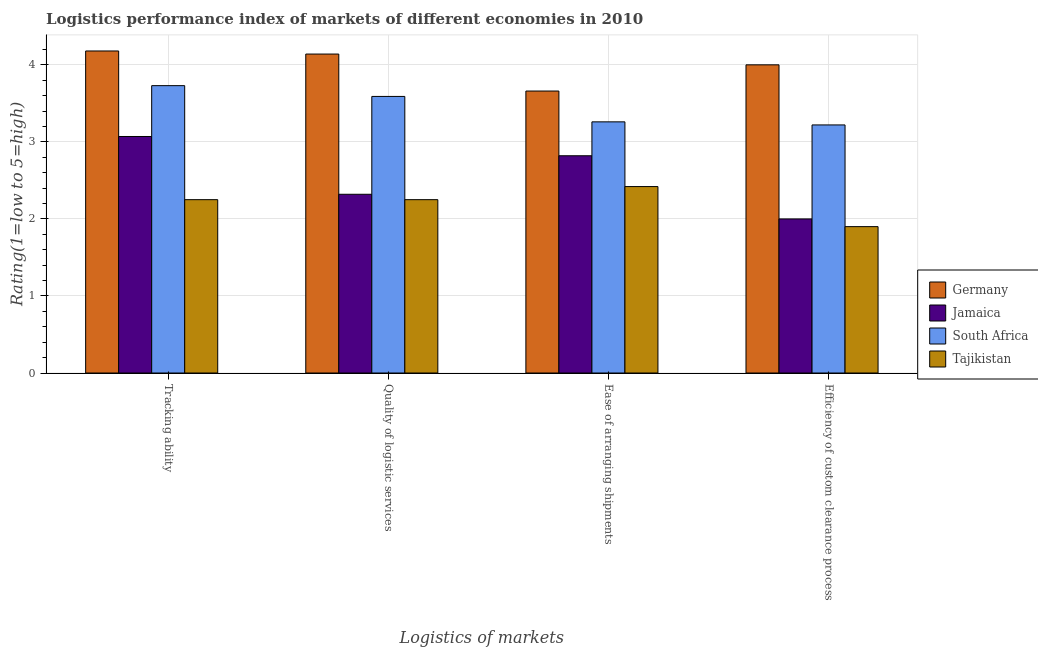How many bars are there on the 1st tick from the left?
Ensure brevity in your answer.  4. What is the label of the 4th group of bars from the left?
Your answer should be compact. Efficiency of custom clearance process. What is the lpi rating of quality of logistic services in Germany?
Keep it short and to the point. 4.14. Across all countries, what is the minimum lpi rating of quality of logistic services?
Provide a short and direct response. 2.25. In which country was the lpi rating of ease of arranging shipments minimum?
Provide a succinct answer. Tajikistan. What is the total lpi rating of quality of logistic services in the graph?
Provide a short and direct response. 12.3. What is the difference between the lpi rating of efficiency of custom clearance process in South Africa and that in Germany?
Your answer should be very brief. -0.78. What is the difference between the lpi rating of quality of logistic services in Jamaica and the lpi rating of tracking ability in Germany?
Offer a terse response. -1.86. What is the average lpi rating of quality of logistic services per country?
Give a very brief answer. 3.07. What is the difference between the lpi rating of efficiency of custom clearance process and lpi rating of tracking ability in Germany?
Give a very brief answer. -0.18. What is the ratio of the lpi rating of efficiency of custom clearance process in Germany to that in Tajikistan?
Make the answer very short. 2.11. Is the difference between the lpi rating of quality of logistic services in Tajikistan and Germany greater than the difference between the lpi rating of ease of arranging shipments in Tajikistan and Germany?
Your answer should be compact. No. What is the difference between the highest and the second highest lpi rating of efficiency of custom clearance process?
Your response must be concise. 0.78. What is the difference between the highest and the lowest lpi rating of quality of logistic services?
Make the answer very short. 1.89. In how many countries, is the lpi rating of quality of logistic services greater than the average lpi rating of quality of logistic services taken over all countries?
Keep it short and to the point. 2. Is it the case that in every country, the sum of the lpi rating of quality of logistic services and lpi rating of efficiency of custom clearance process is greater than the sum of lpi rating of tracking ability and lpi rating of ease of arranging shipments?
Ensure brevity in your answer.  No. What does the 2nd bar from the left in Quality of logistic services represents?
Your answer should be very brief. Jamaica. What does the 2nd bar from the right in Ease of arranging shipments represents?
Your response must be concise. South Africa. How many bars are there?
Your response must be concise. 16. How many countries are there in the graph?
Your answer should be compact. 4. What is the difference between two consecutive major ticks on the Y-axis?
Keep it short and to the point. 1. Are the values on the major ticks of Y-axis written in scientific E-notation?
Your response must be concise. No. Does the graph contain grids?
Offer a terse response. Yes. Where does the legend appear in the graph?
Provide a succinct answer. Center right. How many legend labels are there?
Keep it short and to the point. 4. How are the legend labels stacked?
Your response must be concise. Vertical. What is the title of the graph?
Offer a terse response. Logistics performance index of markets of different economies in 2010. Does "St. Lucia" appear as one of the legend labels in the graph?
Your response must be concise. No. What is the label or title of the X-axis?
Offer a terse response. Logistics of markets. What is the label or title of the Y-axis?
Give a very brief answer. Rating(1=low to 5=high). What is the Rating(1=low to 5=high) of Germany in Tracking ability?
Your response must be concise. 4.18. What is the Rating(1=low to 5=high) of Jamaica in Tracking ability?
Keep it short and to the point. 3.07. What is the Rating(1=low to 5=high) in South Africa in Tracking ability?
Your answer should be very brief. 3.73. What is the Rating(1=low to 5=high) of Tajikistan in Tracking ability?
Offer a very short reply. 2.25. What is the Rating(1=low to 5=high) of Germany in Quality of logistic services?
Give a very brief answer. 4.14. What is the Rating(1=low to 5=high) of Jamaica in Quality of logistic services?
Make the answer very short. 2.32. What is the Rating(1=low to 5=high) in South Africa in Quality of logistic services?
Give a very brief answer. 3.59. What is the Rating(1=low to 5=high) of Tajikistan in Quality of logistic services?
Your response must be concise. 2.25. What is the Rating(1=low to 5=high) of Germany in Ease of arranging shipments?
Make the answer very short. 3.66. What is the Rating(1=low to 5=high) in Jamaica in Ease of arranging shipments?
Offer a very short reply. 2.82. What is the Rating(1=low to 5=high) of South Africa in Ease of arranging shipments?
Keep it short and to the point. 3.26. What is the Rating(1=low to 5=high) of Tajikistan in Ease of arranging shipments?
Your response must be concise. 2.42. What is the Rating(1=low to 5=high) of Germany in Efficiency of custom clearance process?
Offer a very short reply. 4. What is the Rating(1=low to 5=high) of South Africa in Efficiency of custom clearance process?
Offer a terse response. 3.22. Across all Logistics of markets, what is the maximum Rating(1=low to 5=high) of Germany?
Your answer should be compact. 4.18. Across all Logistics of markets, what is the maximum Rating(1=low to 5=high) in Jamaica?
Offer a very short reply. 3.07. Across all Logistics of markets, what is the maximum Rating(1=low to 5=high) in South Africa?
Offer a very short reply. 3.73. Across all Logistics of markets, what is the maximum Rating(1=low to 5=high) of Tajikistan?
Give a very brief answer. 2.42. Across all Logistics of markets, what is the minimum Rating(1=low to 5=high) of Germany?
Offer a very short reply. 3.66. Across all Logistics of markets, what is the minimum Rating(1=low to 5=high) of Jamaica?
Make the answer very short. 2. Across all Logistics of markets, what is the minimum Rating(1=low to 5=high) of South Africa?
Your answer should be very brief. 3.22. Across all Logistics of markets, what is the minimum Rating(1=low to 5=high) in Tajikistan?
Your answer should be compact. 1.9. What is the total Rating(1=low to 5=high) of Germany in the graph?
Offer a terse response. 15.98. What is the total Rating(1=low to 5=high) in Jamaica in the graph?
Make the answer very short. 10.21. What is the total Rating(1=low to 5=high) of Tajikistan in the graph?
Give a very brief answer. 8.82. What is the difference between the Rating(1=low to 5=high) in Germany in Tracking ability and that in Quality of logistic services?
Make the answer very short. 0.04. What is the difference between the Rating(1=low to 5=high) in South Africa in Tracking ability and that in Quality of logistic services?
Offer a very short reply. 0.14. What is the difference between the Rating(1=low to 5=high) of Tajikistan in Tracking ability and that in Quality of logistic services?
Give a very brief answer. 0. What is the difference between the Rating(1=low to 5=high) in Germany in Tracking ability and that in Ease of arranging shipments?
Give a very brief answer. 0.52. What is the difference between the Rating(1=low to 5=high) of Jamaica in Tracking ability and that in Ease of arranging shipments?
Your response must be concise. 0.25. What is the difference between the Rating(1=low to 5=high) of South Africa in Tracking ability and that in Ease of arranging shipments?
Ensure brevity in your answer.  0.47. What is the difference between the Rating(1=low to 5=high) in Tajikistan in Tracking ability and that in Ease of arranging shipments?
Make the answer very short. -0.17. What is the difference between the Rating(1=low to 5=high) of Germany in Tracking ability and that in Efficiency of custom clearance process?
Your answer should be very brief. 0.18. What is the difference between the Rating(1=low to 5=high) of Jamaica in Tracking ability and that in Efficiency of custom clearance process?
Keep it short and to the point. 1.07. What is the difference between the Rating(1=low to 5=high) in South Africa in Tracking ability and that in Efficiency of custom clearance process?
Provide a succinct answer. 0.51. What is the difference between the Rating(1=low to 5=high) of Germany in Quality of logistic services and that in Ease of arranging shipments?
Provide a succinct answer. 0.48. What is the difference between the Rating(1=low to 5=high) in Jamaica in Quality of logistic services and that in Ease of arranging shipments?
Provide a short and direct response. -0.5. What is the difference between the Rating(1=low to 5=high) of South Africa in Quality of logistic services and that in Ease of arranging shipments?
Offer a terse response. 0.33. What is the difference between the Rating(1=low to 5=high) in Tajikistan in Quality of logistic services and that in Ease of arranging shipments?
Provide a short and direct response. -0.17. What is the difference between the Rating(1=low to 5=high) of Germany in Quality of logistic services and that in Efficiency of custom clearance process?
Provide a short and direct response. 0.14. What is the difference between the Rating(1=low to 5=high) in Jamaica in Quality of logistic services and that in Efficiency of custom clearance process?
Make the answer very short. 0.32. What is the difference between the Rating(1=low to 5=high) of South Africa in Quality of logistic services and that in Efficiency of custom clearance process?
Offer a terse response. 0.37. What is the difference between the Rating(1=low to 5=high) of Germany in Ease of arranging shipments and that in Efficiency of custom clearance process?
Keep it short and to the point. -0.34. What is the difference between the Rating(1=low to 5=high) in Jamaica in Ease of arranging shipments and that in Efficiency of custom clearance process?
Your answer should be compact. 0.82. What is the difference between the Rating(1=low to 5=high) in Tajikistan in Ease of arranging shipments and that in Efficiency of custom clearance process?
Give a very brief answer. 0.52. What is the difference between the Rating(1=low to 5=high) of Germany in Tracking ability and the Rating(1=low to 5=high) of Jamaica in Quality of logistic services?
Keep it short and to the point. 1.86. What is the difference between the Rating(1=low to 5=high) of Germany in Tracking ability and the Rating(1=low to 5=high) of South Africa in Quality of logistic services?
Make the answer very short. 0.59. What is the difference between the Rating(1=low to 5=high) in Germany in Tracking ability and the Rating(1=low to 5=high) in Tajikistan in Quality of logistic services?
Make the answer very short. 1.93. What is the difference between the Rating(1=low to 5=high) in Jamaica in Tracking ability and the Rating(1=low to 5=high) in South Africa in Quality of logistic services?
Offer a terse response. -0.52. What is the difference between the Rating(1=low to 5=high) of Jamaica in Tracking ability and the Rating(1=low to 5=high) of Tajikistan in Quality of logistic services?
Keep it short and to the point. 0.82. What is the difference between the Rating(1=low to 5=high) of South Africa in Tracking ability and the Rating(1=low to 5=high) of Tajikistan in Quality of logistic services?
Give a very brief answer. 1.48. What is the difference between the Rating(1=low to 5=high) in Germany in Tracking ability and the Rating(1=low to 5=high) in Jamaica in Ease of arranging shipments?
Keep it short and to the point. 1.36. What is the difference between the Rating(1=low to 5=high) in Germany in Tracking ability and the Rating(1=low to 5=high) in South Africa in Ease of arranging shipments?
Offer a terse response. 0.92. What is the difference between the Rating(1=low to 5=high) in Germany in Tracking ability and the Rating(1=low to 5=high) in Tajikistan in Ease of arranging shipments?
Your answer should be compact. 1.76. What is the difference between the Rating(1=low to 5=high) of Jamaica in Tracking ability and the Rating(1=low to 5=high) of South Africa in Ease of arranging shipments?
Make the answer very short. -0.19. What is the difference between the Rating(1=low to 5=high) of Jamaica in Tracking ability and the Rating(1=low to 5=high) of Tajikistan in Ease of arranging shipments?
Provide a short and direct response. 0.65. What is the difference between the Rating(1=low to 5=high) of South Africa in Tracking ability and the Rating(1=low to 5=high) of Tajikistan in Ease of arranging shipments?
Keep it short and to the point. 1.31. What is the difference between the Rating(1=low to 5=high) of Germany in Tracking ability and the Rating(1=low to 5=high) of Jamaica in Efficiency of custom clearance process?
Make the answer very short. 2.18. What is the difference between the Rating(1=low to 5=high) of Germany in Tracking ability and the Rating(1=low to 5=high) of South Africa in Efficiency of custom clearance process?
Keep it short and to the point. 0.96. What is the difference between the Rating(1=low to 5=high) in Germany in Tracking ability and the Rating(1=low to 5=high) in Tajikistan in Efficiency of custom clearance process?
Keep it short and to the point. 2.28. What is the difference between the Rating(1=low to 5=high) of Jamaica in Tracking ability and the Rating(1=low to 5=high) of South Africa in Efficiency of custom clearance process?
Your answer should be compact. -0.15. What is the difference between the Rating(1=low to 5=high) of Jamaica in Tracking ability and the Rating(1=low to 5=high) of Tajikistan in Efficiency of custom clearance process?
Make the answer very short. 1.17. What is the difference between the Rating(1=low to 5=high) of South Africa in Tracking ability and the Rating(1=low to 5=high) of Tajikistan in Efficiency of custom clearance process?
Keep it short and to the point. 1.83. What is the difference between the Rating(1=low to 5=high) of Germany in Quality of logistic services and the Rating(1=low to 5=high) of Jamaica in Ease of arranging shipments?
Your answer should be very brief. 1.32. What is the difference between the Rating(1=low to 5=high) in Germany in Quality of logistic services and the Rating(1=low to 5=high) in South Africa in Ease of arranging shipments?
Offer a very short reply. 0.88. What is the difference between the Rating(1=low to 5=high) in Germany in Quality of logistic services and the Rating(1=low to 5=high) in Tajikistan in Ease of arranging shipments?
Offer a terse response. 1.72. What is the difference between the Rating(1=low to 5=high) in Jamaica in Quality of logistic services and the Rating(1=low to 5=high) in South Africa in Ease of arranging shipments?
Offer a terse response. -0.94. What is the difference between the Rating(1=low to 5=high) in South Africa in Quality of logistic services and the Rating(1=low to 5=high) in Tajikistan in Ease of arranging shipments?
Ensure brevity in your answer.  1.17. What is the difference between the Rating(1=low to 5=high) of Germany in Quality of logistic services and the Rating(1=low to 5=high) of Jamaica in Efficiency of custom clearance process?
Ensure brevity in your answer.  2.14. What is the difference between the Rating(1=low to 5=high) of Germany in Quality of logistic services and the Rating(1=low to 5=high) of South Africa in Efficiency of custom clearance process?
Make the answer very short. 0.92. What is the difference between the Rating(1=low to 5=high) of Germany in Quality of logistic services and the Rating(1=low to 5=high) of Tajikistan in Efficiency of custom clearance process?
Make the answer very short. 2.24. What is the difference between the Rating(1=low to 5=high) of Jamaica in Quality of logistic services and the Rating(1=low to 5=high) of South Africa in Efficiency of custom clearance process?
Your answer should be compact. -0.9. What is the difference between the Rating(1=low to 5=high) of Jamaica in Quality of logistic services and the Rating(1=low to 5=high) of Tajikistan in Efficiency of custom clearance process?
Your answer should be very brief. 0.42. What is the difference between the Rating(1=low to 5=high) in South Africa in Quality of logistic services and the Rating(1=low to 5=high) in Tajikistan in Efficiency of custom clearance process?
Your response must be concise. 1.69. What is the difference between the Rating(1=low to 5=high) in Germany in Ease of arranging shipments and the Rating(1=low to 5=high) in Jamaica in Efficiency of custom clearance process?
Ensure brevity in your answer.  1.66. What is the difference between the Rating(1=low to 5=high) of Germany in Ease of arranging shipments and the Rating(1=low to 5=high) of South Africa in Efficiency of custom clearance process?
Make the answer very short. 0.44. What is the difference between the Rating(1=low to 5=high) in Germany in Ease of arranging shipments and the Rating(1=low to 5=high) in Tajikistan in Efficiency of custom clearance process?
Keep it short and to the point. 1.76. What is the difference between the Rating(1=low to 5=high) of Jamaica in Ease of arranging shipments and the Rating(1=low to 5=high) of South Africa in Efficiency of custom clearance process?
Offer a terse response. -0.4. What is the difference between the Rating(1=low to 5=high) of Jamaica in Ease of arranging shipments and the Rating(1=low to 5=high) of Tajikistan in Efficiency of custom clearance process?
Offer a terse response. 0.92. What is the difference between the Rating(1=low to 5=high) of South Africa in Ease of arranging shipments and the Rating(1=low to 5=high) of Tajikistan in Efficiency of custom clearance process?
Give a very brief answer. 1.36. What is the average Rating(1=low to 5=high) in Germany per Logistics of markets?
Provide a short and direct response. 4. What is the average Rating(1=low to 5=high) of Jamaica per Logistics of markets?
Ensure brevity in your answer.  2.55. What is the average Rating(1=low to 5=high) in South Africa per Logistics of markets?
Keep it short and to the point. 3.45. What is the average Rating(1=low to 5=high) in Tajikistan per Logistics of markets?
Offer a terse response. 2.21. What is the difference between the Rating(1=low to 5=high) of Germany and Rating(1=low to 5=high) of Jamaica in Tracking ability?
Offer a terse response. 1.11. What is the difference between the Rating(1=low to 5=high) of Germany and Rating(1=low to 5=high) of South Africa in Tracking ability?
Provide a succinct answer. 0.45. What is the difference between the Rating(1=low to 5=high) of Germany and Rating(1=low to 5=high) of Tajikistan in Tracking ability?
Make the answer very short. 1.93. What is the difference between the Rating(1=low to 5=high) in Jamaica and Rating(1=low to 5=high) in South Africa in Tracking ability?
Your response must be concise. -0.66. What is the difference between the Rating(1=low to 5=high) of Jamaica and Rating(1=low to 5=high) of Tajikistan in Tracking ability?
Your answer should be compact. 0.82. What is the difference between the Rating(1=low to 5=high) of South Africa and Rating(1=low to 5=high) of Tajikistan in Tracking ability?
Your response must be concise. 1.48. What is the difference between the Rating(1=low to 5=high) of Germany and Rating(1=low to 5=high) of Jamaica in Quality of logistic services?
Keep it short and to the point. 1.82. What is the difference between the Rating(1=low to 5=high) in Germany and Rating(1=low to 5=high) in South Africa in Quality of logistic services?
Your answer should be compact. 0.55. What is the difference between the Rating(1=low to 5=high) in Germany and Rating(1=low to 5=high) in Tajikistan in Quality of logistic services?
Offer a very short reply. 1.89. What is the difference between the Rating(1=low to 5=high) in Jamaica and Rating(1=low to 5=high) in South Africa in Quality of logistic services?
Give a very brief answer. -1.27. What is the difference between the Rating(1=low to 5=high) of Jamaica and Rating(1=low to 5=high) of Tajikistan in Quality of logistic services?
Offer a terse response. 0.07. What is the difference between the Rating(1=low to 5=high) of South Africa and Rating(1=low to 5=high) of Tajikistan in Quality of logistic services?
Make the answer very short. 1.34. What is the difference between the Rating(1=low to 5=high) of Germany and Rating(1=low to 5=high) of Jamaica in Ease of arranging shipments?
Ensure brevity in your answer.  0.84. What is the difference between the Rating(1=low to 5=high) in Germany and Rating(1=low to 5=high) in South Africa in Ease of arranging shipments?
Offer a very short reply. 0.4. What is the difference between the Rating(1=low to 5=high) of Germany and Rating(1=low to 5=high) of Tajikistan in Ease of arranging shipments?
Offer a very short reply. 1.24. What is the difference between the Rating(1=low to 5=high) in Jamaica and Rating(1=low to 5=high) in South Africa in Ease of arranging shipments?
Your response must be concise. -0.44. What is the difference between the Rating(1=low to 5=high) of Jamaica and Rating(1=low to 5=high) of Tajikistan in Ease of arranging shipments?
Your answer should be compact. 0.4. What is the difference between the Rating(1=low to 5=high) of South Africa and Rating(1=low to 5=high) of Tajikistan in Ease of arranging shipments?
Offer a very short reply. 0.84. What is the difference between the Rating(1=low to 5=high) in Germany and Rating(1=low to 5=high) in Jamaica in Efficiency of custom clearance process?
Make the answer very short. 2. What is the difference between the Rating(1=low to 5=high) in Germany and Rating(1=low to 5=high) in South Africa in Efficiency of custom clearance process?
Your answer should be very brief. 0.78. What is the difference between the Rating(1=low to 5=high) of Jamaica and Rating(1=low to 5=high) of South Africa in Efficiency of custom clearance process?
Provide a short and direct response. -1.22. What is the difference between the Rating(1=low to 5=high) of Jamaica and Rating(1=low to 5=high) of Tajikistan in Efficiency of custom clearance process?
Your answer should be very brief. 0.1. What is the difference between the Rating(1=low to 5=high) in South Africa and Rating(1=low to 5=high) in Tajikistan in Efficiency of custom clearance process?
Provide a short and direct response. 1.32. What is the ratio of the Rating(1=low to 5=high) of Germany in Tracking ability to that in Quality of logistic services?
Your answer should be compact. 1.01. What is the ratio of the Rating(1=low to 5=high) in Jamaica in Tracking ability to that in Quality of logistic services?
Make the answer very short. 1.32. What is the ratio of the Rating(1=low to 5=high) in South Africa in Tracking ability to that in Quality of logistic services?
Ensure brevity in your answer.  1.04. What is the ratio of the Rating(1=low to 5=high) in Germany in Tracking ability to that in Ease of arranging shipments?
Offer a very short reply. 1.14. What is the ratio of the Rating(1=low to 5=high) of Jamaica in Tracking ability to that in Ease of arranging shipments?
Keep it short and to the point. 1.09. What is the ratio of the Rating(1=low to 5=high) of South Africa in Tracking ability to that in Ease of arranging shipments?
Ensure brevity in your answer.  1.14. What is the ratio of the Rating(1=low to 5=high) in Tajikistan in Tracking ability to that in Ease of arranging shipments?
Make the answer very short. 0.93. What is the ratio of the Rating(1=low to 5=high) in Germany in Tracking ability to that in Efficiency of custom clearance process?
Give a very brief answer. 1.04. What is the ratio of the Rating(1=low to 5=high) of Jamaica in Tracking ability to that in Efficiency of custom clearance process?
Your answer should be compact. 1.53. What is the ratio of the Rating(1=low to 5=high) of South Africa in Tracking ability to that in Efficiency of custom clearance process?
Give a very brief answer. 1.16. What is the ratio of the Rating(1=low to 5=high) of Tajikistan in Tracking ability to that in Efficiency of custom clearance process?
Give a very brief answer. 1.18. What is the ratio of the Rating(1=low to 5=high) of Germany in Quality of logistic services to that in Ease of arranging shipments?
Keep it short and to the point. 1.13. What is the ratio of the Rating(1=low to 5=high) of Jamaica in Quality of logistic services to that in Ease of arranging shipments?
Your response must be concise. 0.82. What is the ratio of the Rating(1=low to 5=high) in South Africa in Quality of logistic services to that in Ease of arranging shipments?
Offer a very short reply. 1.1. What is the ratio of the Rating(1=low to 5=high) in Tajikistan in Quality of logistic services to that in Ease of arranging shipments?
Your answer should be compact. 0.93. What is the ratio of the Rating(1=low to 5=high) of Germany in Quality of logistic services to that in Efficiency of custom clearance process?
Offer a terse response. 1.03. What is the ratio of the Rating(1=low to 5=high) of Jamaica in Quality of logistic services to that in Efficiency of custom clearance process?
Make the answer very short. 1.16. What is the ratio of the Rating(1=low to 5=high) of South Africa in Quality of logistic services to that in Efficiency of custom clearance process?
Your answer should be very brief. 1.11. What is the ratio of the Rating(1=low to 5=high) in Tajikistan in Quality of logistic services to that in Efficiency of custom clearance process?
Provide a succinct answer. 1.18. What is the ratio of the Rating(1=low to 5=high) in Germany in Ease of arranging shipments to that in Efficiency of custom clearance process?
Offer a very short reply. 0.92. What is the ratio of the Rating(1=low to 5=high) in Jamaica in Ease of arranging shipments to that in Efficiency of custom clearance process?
Your response must be concise. 1.41. What is the ratio of the Rating(1=low to 5=high) in South Africa in Ease of arranging shipments to that in Efficiency of custom clearance process?
Give a very brief answer. 1.01. What is the ratio of the Rating(1=low to 5=high) in Tajikistan in Ease of arranging shipments to that in Efficiency of custom clearance process?
Ensure brevity in your answer.  1.27. What is the difference between the highest and the second highest Rating(1=low to 5=high) in Germany?
Offer a very short reply. 0.04. What is the difference between the highest and the second highest Rating(1=low to 5=high) of South Africa?
Provide a short and direct response. 0.14. What is the difference between the highest and the second highest Rating(1=low to 5=high) of Tajikistan?
Ensure brevity in your answer.  0.17. What is the difference between the highest and the lowest Rating(1=low to 5=high) in Germany?
Ensure brevity in your answer.  0.52. What is the difference between the highest and the lowest Rating(1=low to 5=high) of Jamaica?
Your answer should be compact. 1.07. What is the difference between the highest and the lowest Rating(1=low to 5=high) in South Africa?
Ensure brevity in your answer.  0.51. What is the difference between the highest and the lowest Rating(1=low to 5=high) of Tajikistan?
Your response must be concise. 0.52. 